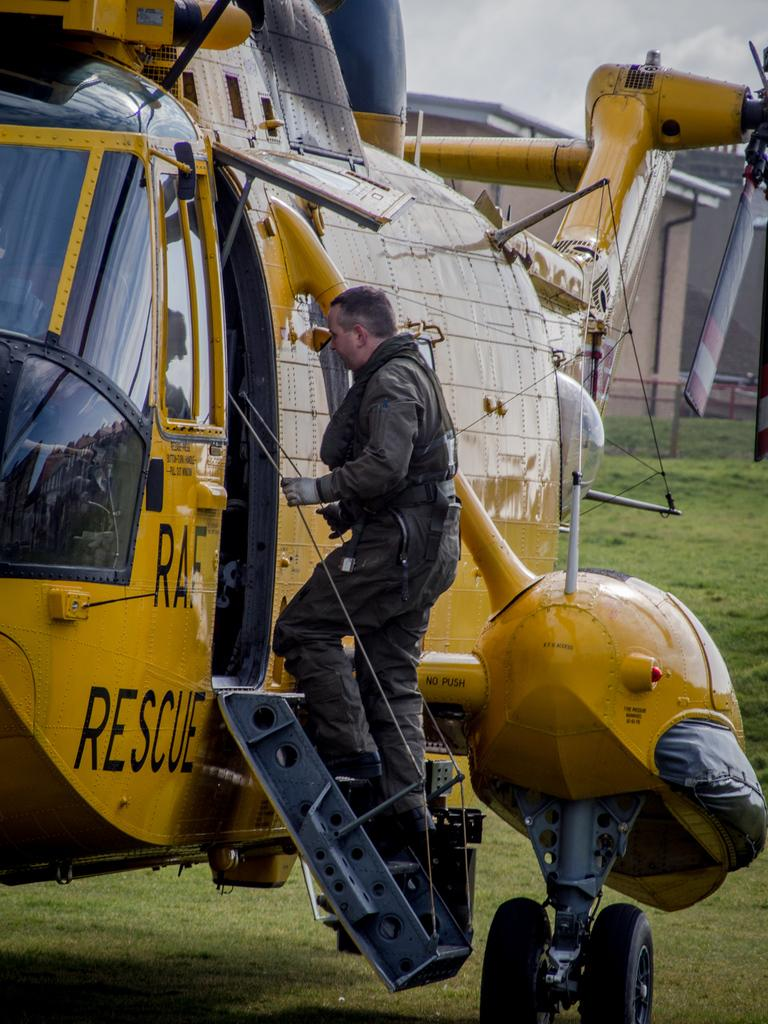What is the main subject of the image? The main subject of the image is a helicopter. What is the man in the image doing? The man is standing on the steps of the helicopter. What can be seen in the background of the image? There is a building, a board, grass, and the sky visible in the background of the image. What type of stew is being prepared in the helicopter? There is no stew being prepared in the helicopter; the image only shows a helicopter with a man standing on its steps. 